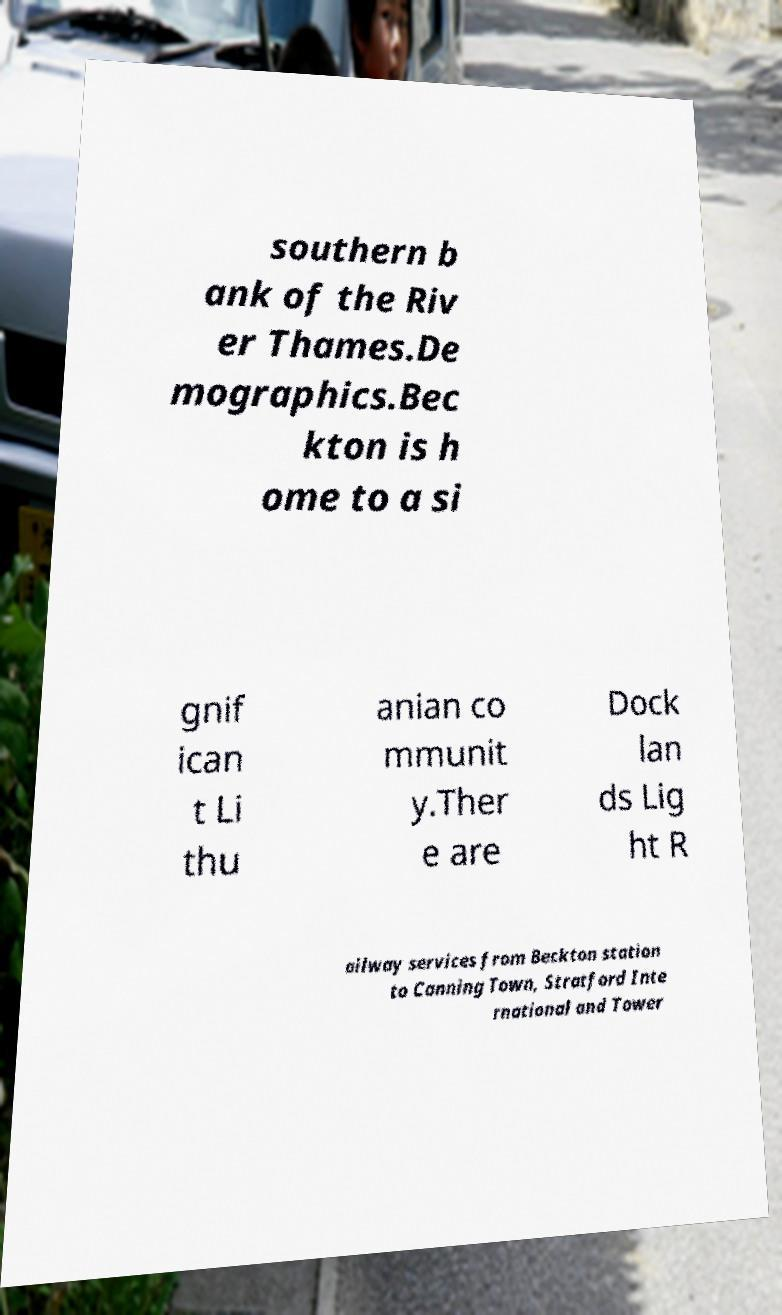For documentation purposes, I need the text within this image transcribed. Could you provide that? southern b ank of the Riv er Thames.De mographics.Bec kton is h ome to a si gnif ican t Li thu anian co mmunit y.Ther e are Dock lan ds Lig ht R ailway services from Beckton station to Canning Town, Stratford Inte rnational and Tower 